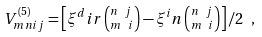<formula> <loc_0><loc_0><loc_500><loc_500>V _ { m n i j } ^ { ( 5 ) } = \left [ \xi ^ { d } i r \left ( ^ { n \ j } _ { m \ i } \right ) - \xi ^ { i } n \left ( ^ { n \ j } _ { m \ i } \right ) \right ] / 2 \ ,</formula> 